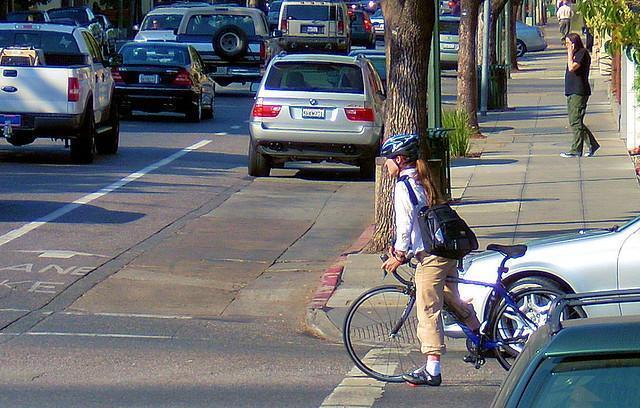How many persons can be seen in this picture?
Give a very brief answer. 3. How many trucks are there?
Give a very brief answer. 2. How many cars are in the picture?
Give a very brief answer. 6. How many people are in the picture?
Give a very brief answer. 2. 